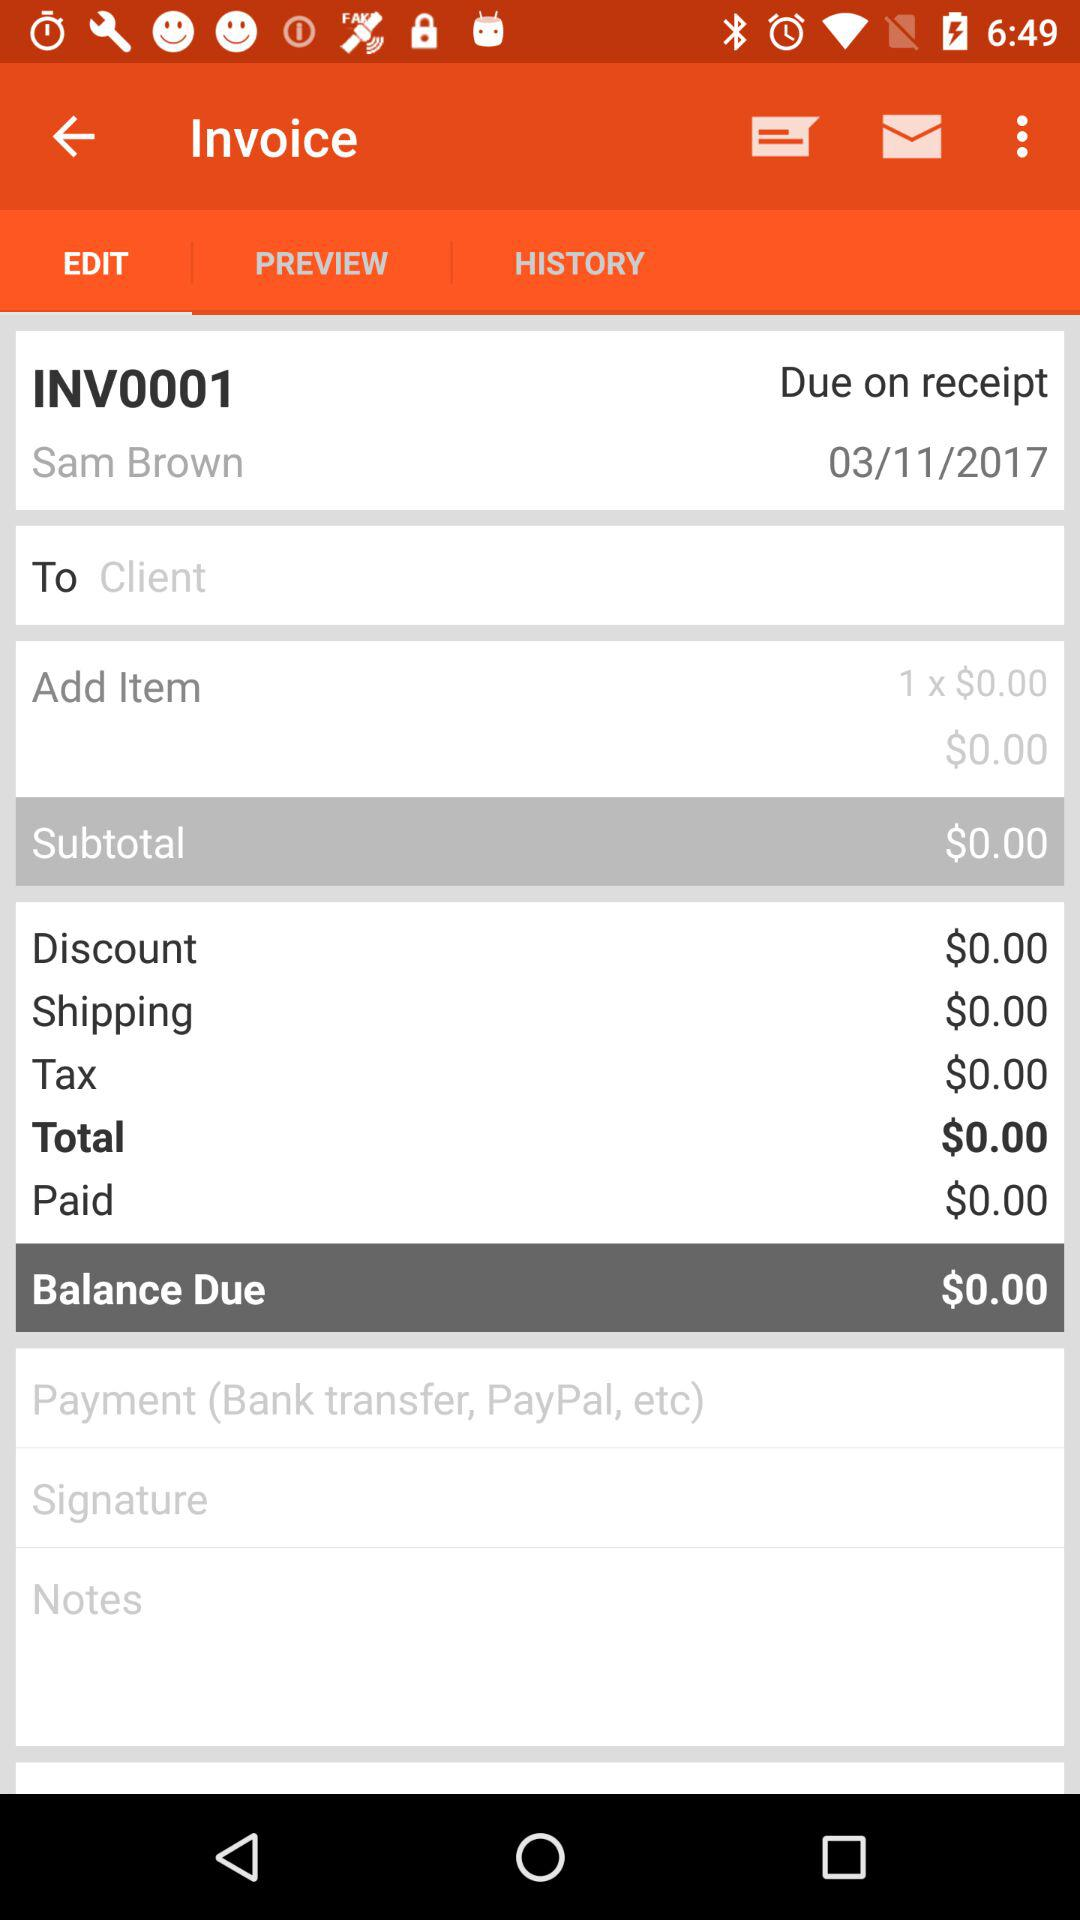What is the subtotal amount? The subtotal amount is $0. 